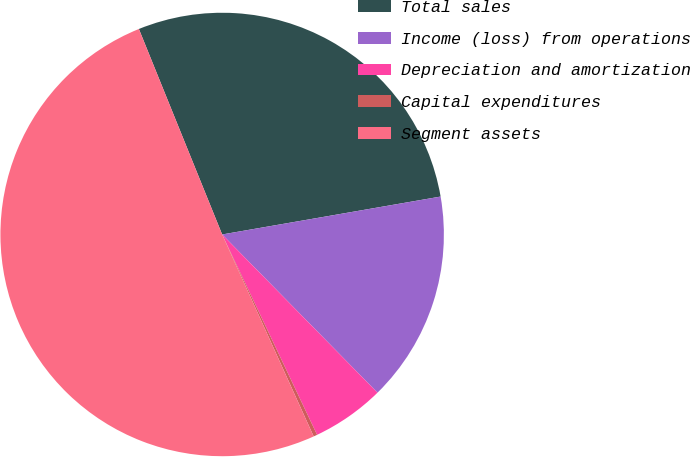<chart> <loc_0><loc_0><loc_500><loc_500><pie_chart><fcel>Total sales<fcel>Income (loss) from operations<fcel>Depreciation and amortization<fcel>Capital expenditures<fcel>Segment assets<nl><fcel>28.39%<fcel>15.38%<fcel>5.31%<fcel>0.27%<fcel>50.64%<nl></chart> 